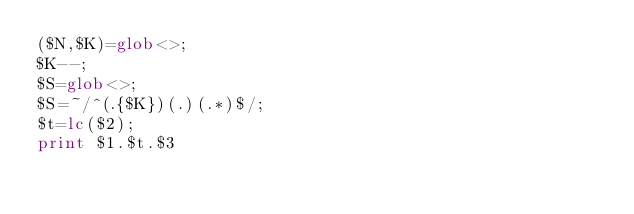Convert code to text. <code><loc_0><loc_0><loc_500><loc_500><_Perl_>($N,$K)=glob<>;
$K--;
$S=glob<>;
$S=~/^(.{$K})(.)(.*)$/;
$t=lc($2);
print $1.$t.$3</code> 